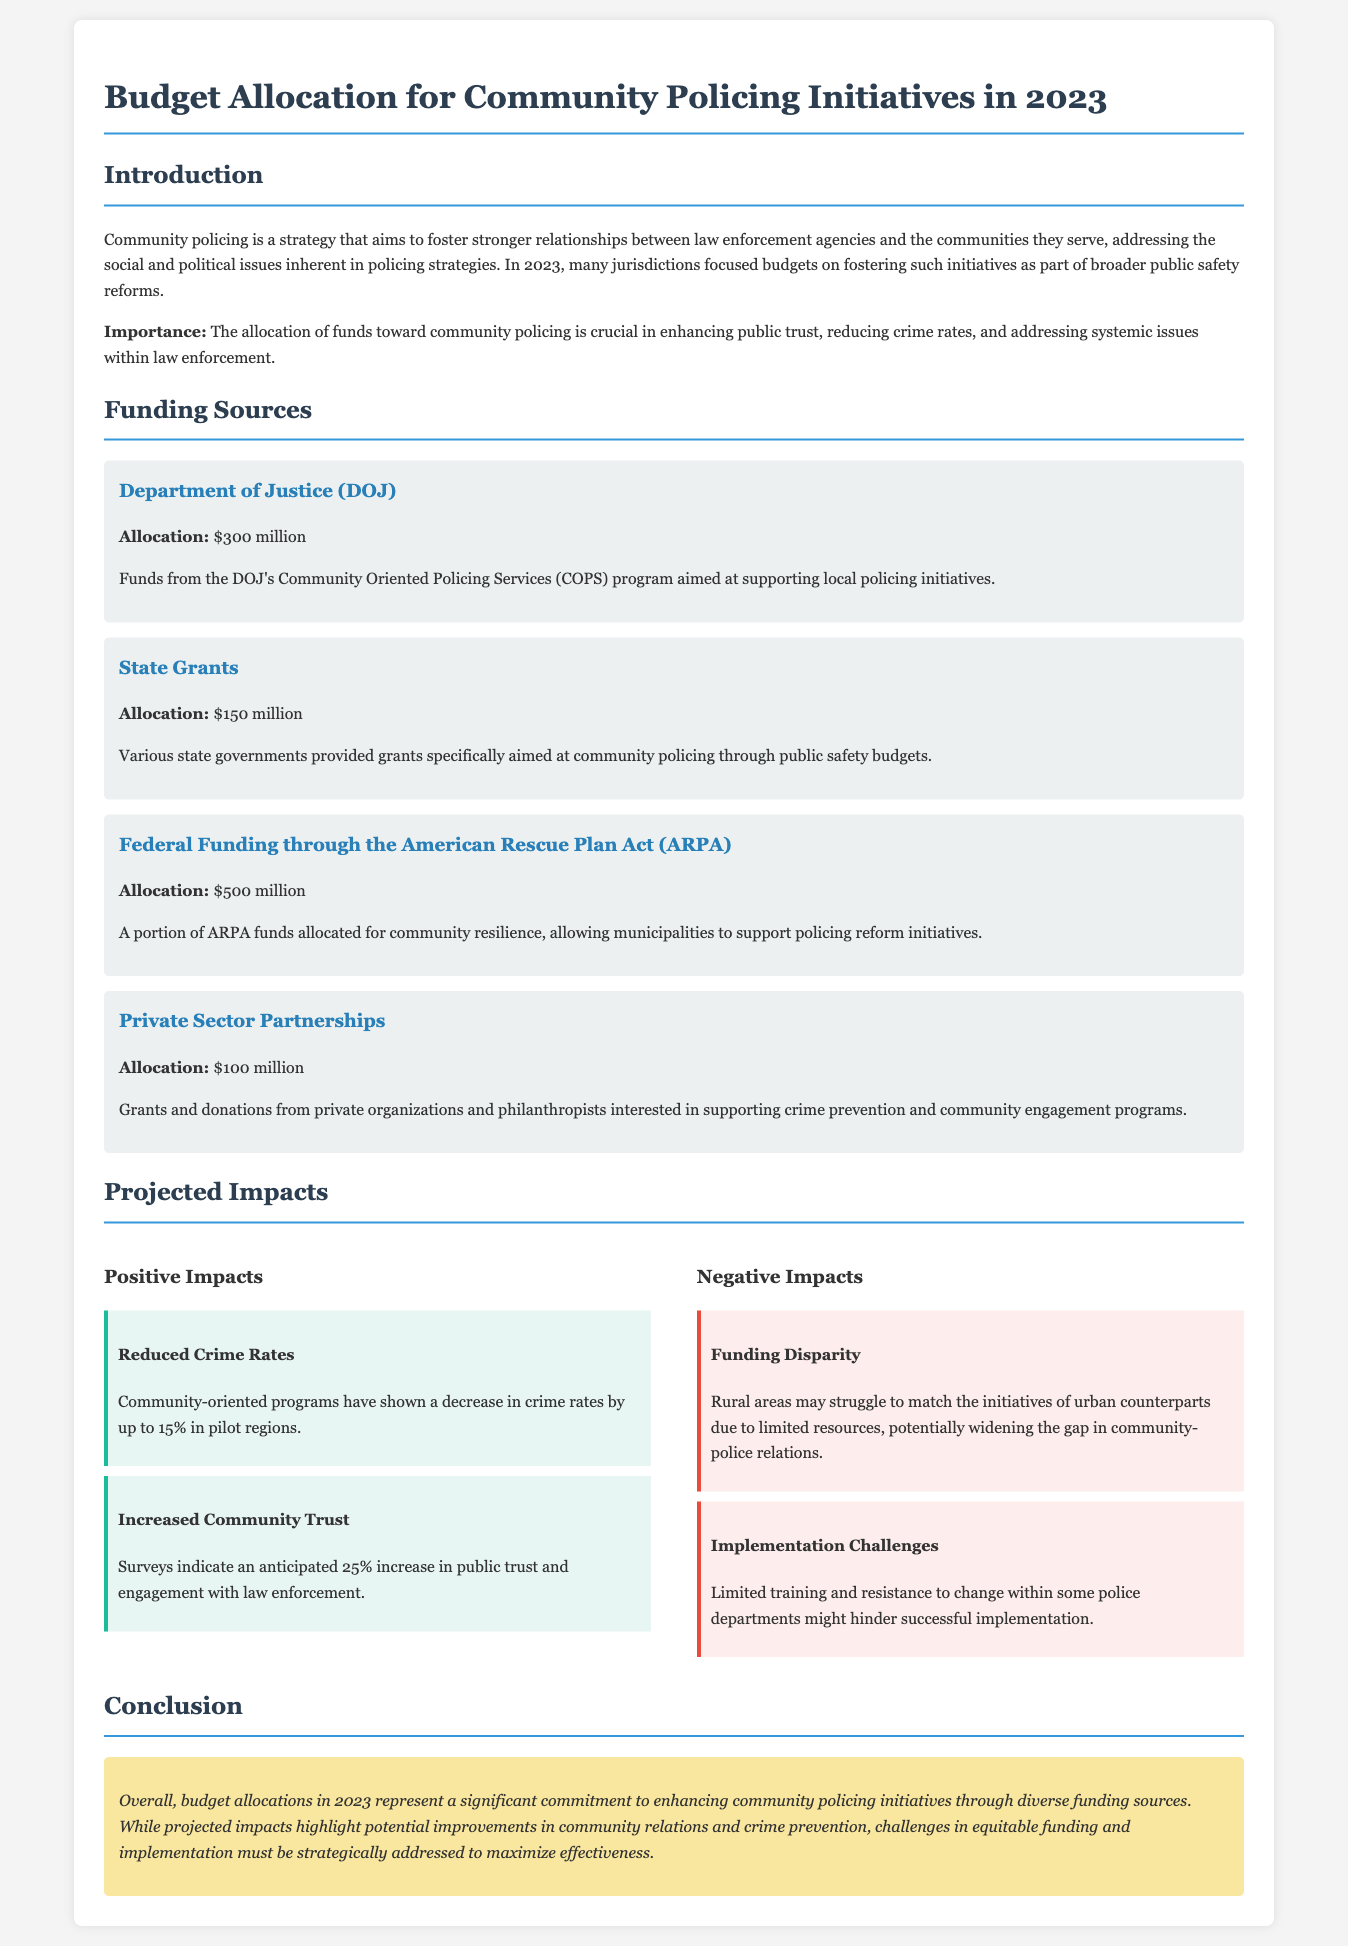What is the total budget allocation for community policing initiatives in 2023? The total budget allocation is the sum of all the specified funding sources in the document: $300 million + $150 million + $500 million + $100 million = $1.05 billion.
Answer: $1.05 billion What is the largest funding source for community policing initiatives? The largest funding source is mentioned in the funding sources section, which is the Federal Funding through the American Rescue Plan Act, amounting to $500 million.
Answer: $500 million What percentage increase in public trust is anticipated with community policing initiatives? The document states that surveys indicate an anticipated 25% increase in public trust and engagement with law enforcement.
Answer: 25% What are the two types of projected impacts discussed in the document? The document categorizes projected impacts into Positive Impacts and Negative Impacts with specific examples in each category.
Answer: Positive Impacts and Negative Impacts Which organization provides $300 million for community policing? The funding source specified in the document that allocates $300 million is the Department of Justice (DOJ).
Answer: Department of Justice (DOJ) What challenge is mentioned that could hinder successful implementation of community policing? The document identifies limited training and resistance to change within some police departments as challenges in successful implementation.
Answer: Limited training and resistance to change What is the impact of community-oriented programs on crime rates according to the document? The document provides information indicating that community-oriented programs have shown a decrease in crime rates by up to 15% in pilot regions.
Answer: Decrease by up to 15% What is the conclusion's general sentiment regarding the budget allocation? The conclusion expresses a significant commitment to enhancing community policing initiatives while acknowledging challenges that must be addressed.
Answer: Significant commitment 